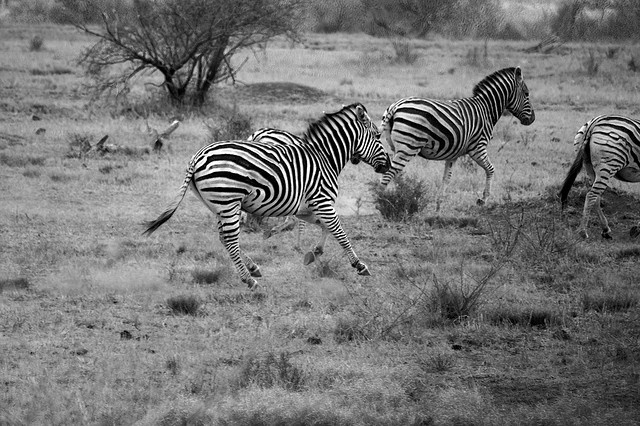Describe the objects in this image and their specific colors. I can see zebra in gray, black, darkgray, and lightgray tones, zebra in gray, black, darkgray, and lightgray tones, zebra in gray, black, darkgray, and lightgray tones, and zebra in gray, darkgray, white, and black tones in this image. 